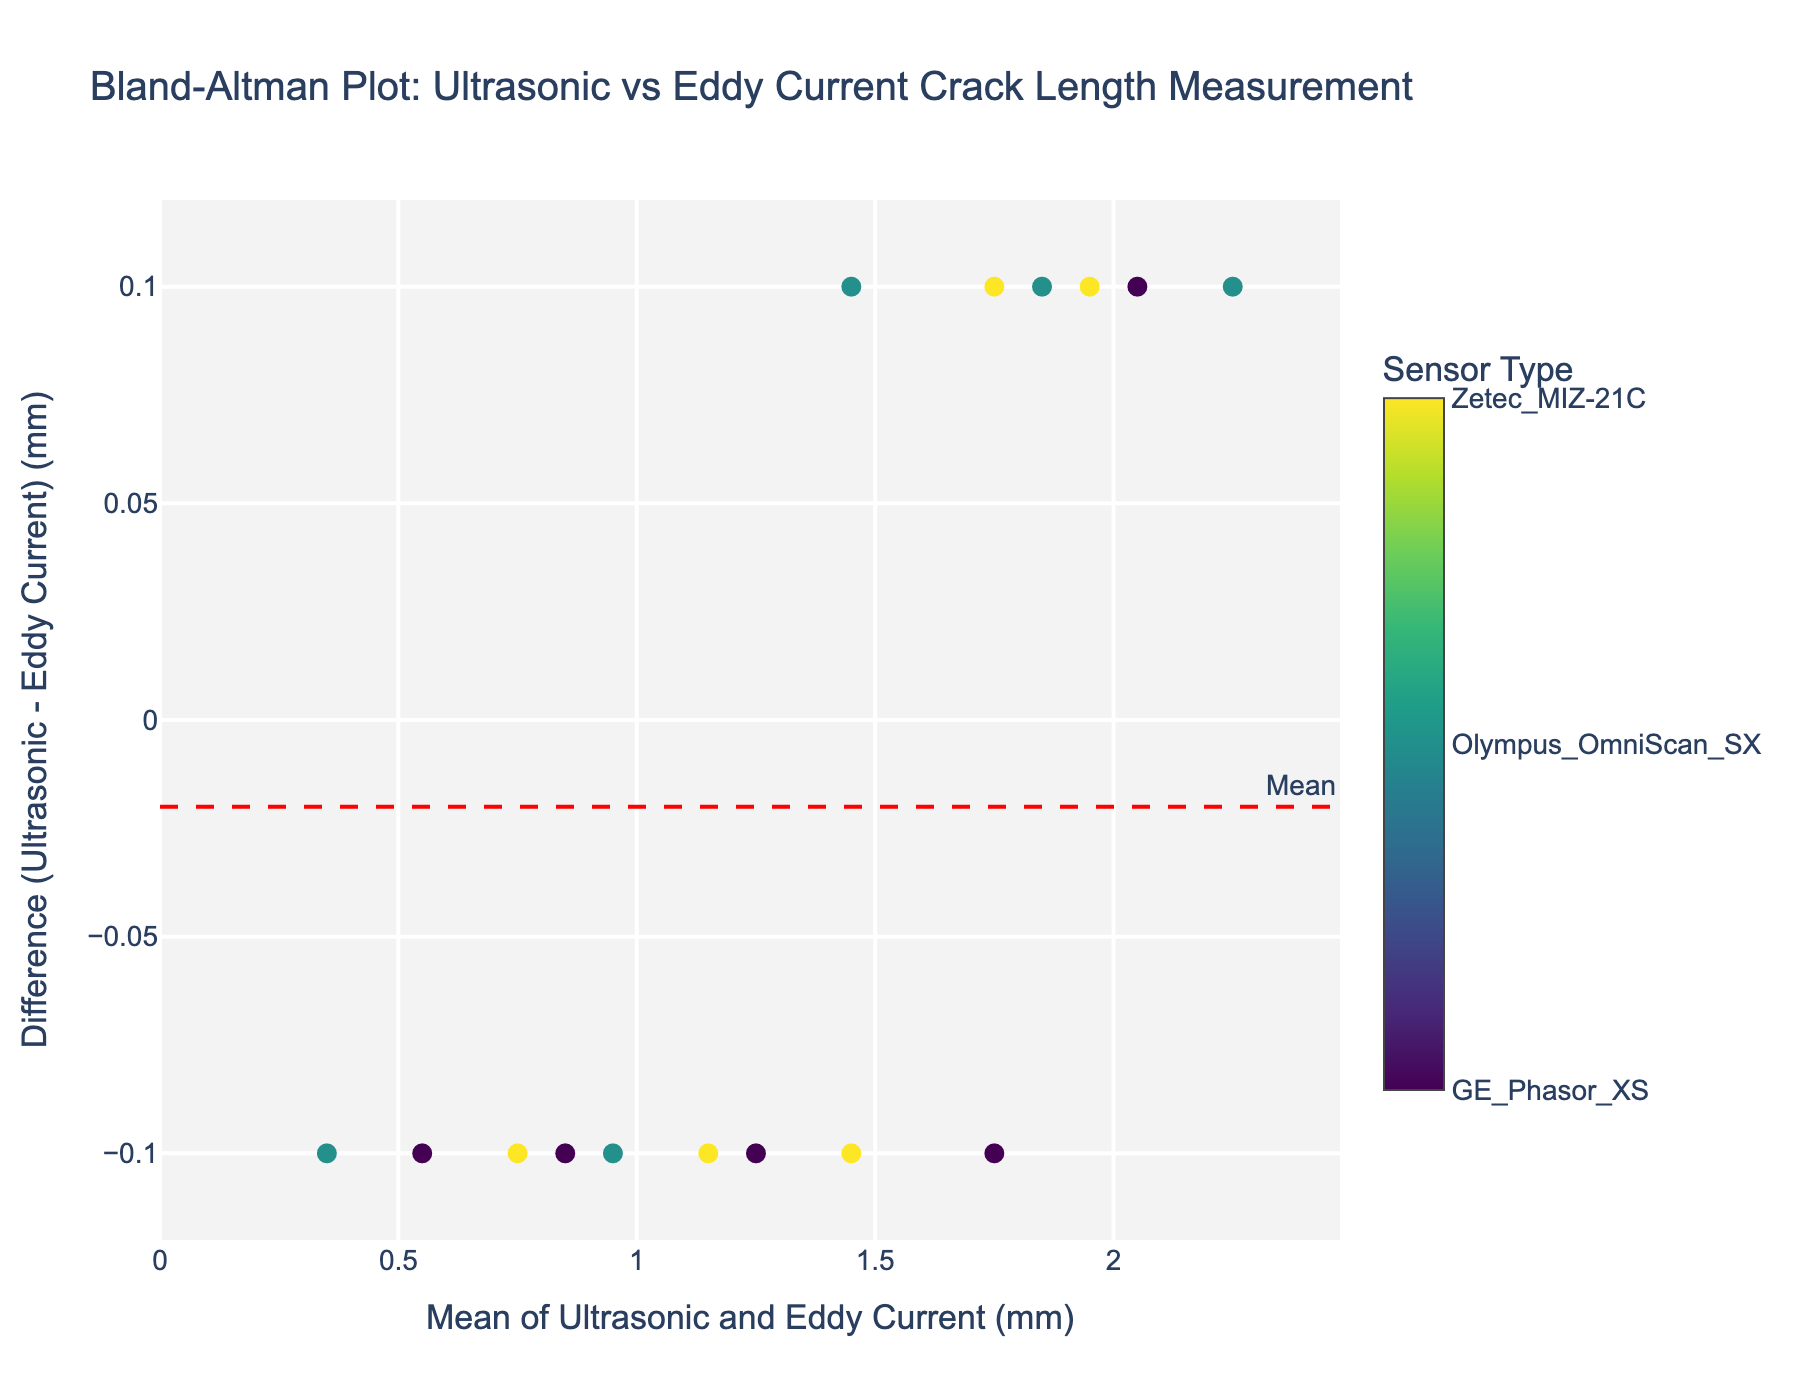How many data points are shown in the plot? By visually inspecting the figure, count the number of markers representing the data points. Each marker corresponds to one pair of measurements.
Answer: 15 What's the mean difference between the two measurement methods? The red dashed line in the figure represents the mean difference between the ultrasonic and eddy current measurements. This annotation is labeled "Mean" and marked on the y-axis.
Answer: 0.03 mm What sensor type is represented by the green color in the plot? By matching the color scale on the color bar to the sensor types, find the specific sensor type associated with the color green. The sensor types are categorized and listed on the color bar with their respective color codes.
Answer: Olympus_OmniScan_SX Are there more data points above or below the mean difference line? Count the number of markers above the red dashed mean line and compare it to the number below this line.
Answer: Below What are the upper and lower limits of agreement? The green dotted lines represent the limits of agreement, which are labeled on the plot as "+1.96 SD" and "-1.96 SD." By reading the positions of these lines on the y-axis, we can identify the limits of agreement.
Answer: Upper: 0.14 mm, Lower: -0.08 mm What is the range of the differences plotted on the y-axis? The range can be determined by finding the minimum and maximum y-values of the data points. The markers' vertical positions indicate the differences between the measurements for each data point.
Answer: -0.1 mm to 0.1 mm What's the average of the upper and lower limits of agreement? To find the average, add the upper and lower limits of agreement and then divide by 2. The limits are +0.14 mm and -0.08 mm. So, (0.14 + (-0.08)) / 2 = 0.03.
Answer: 0.03 mm Which sensor type has the smallest overall differences between the two methods? By observing the positions of the markers near the mean difference line and checking the sensor types in the hover text, identify which sensor type stays closest to the mean difference line.
Answer: GE_Phasor_XS What observations can be made about the consistency of the ultrasonic vs. eddy current measurements based on the plot? Evaluate the spread of the data points relative to the mean difference line and limits of agreement. Consistency is indicated by data points clustering closely around the mean difference line and within the limits. If the data points are widely scattered, this implies inconsistency.
Answer: Generally consistent, but some variability 